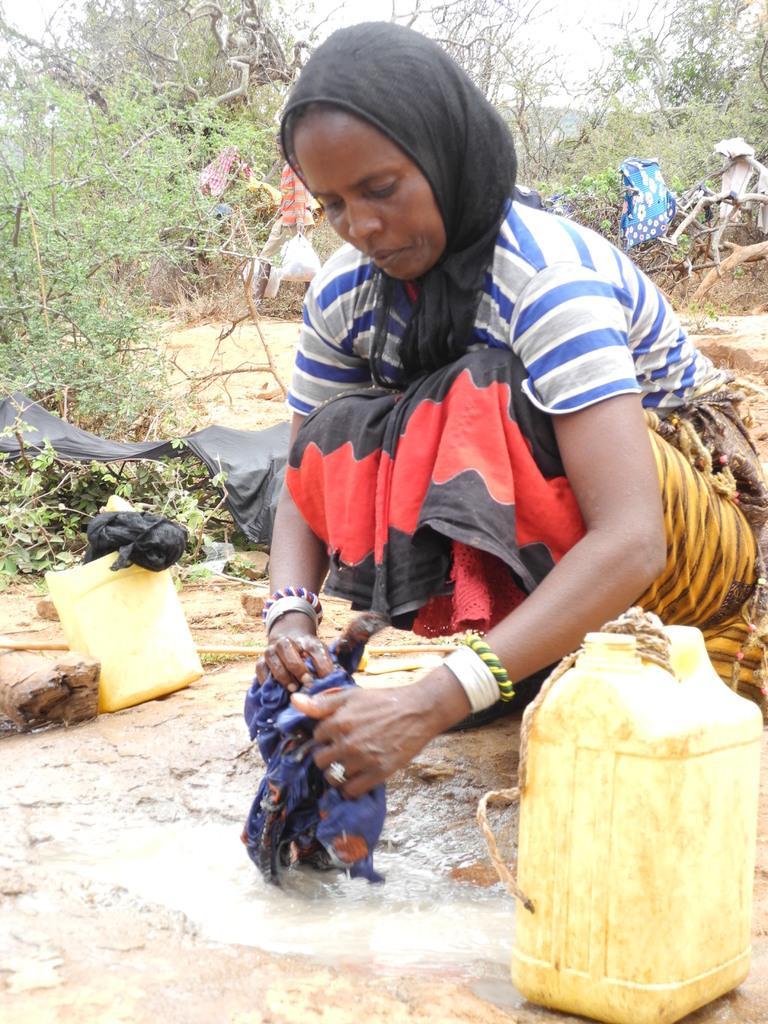How would you summarize this image in a sentence or two? This woman is in squad position and holding a cloth. These are water cans. Here we can see plants and trees. 